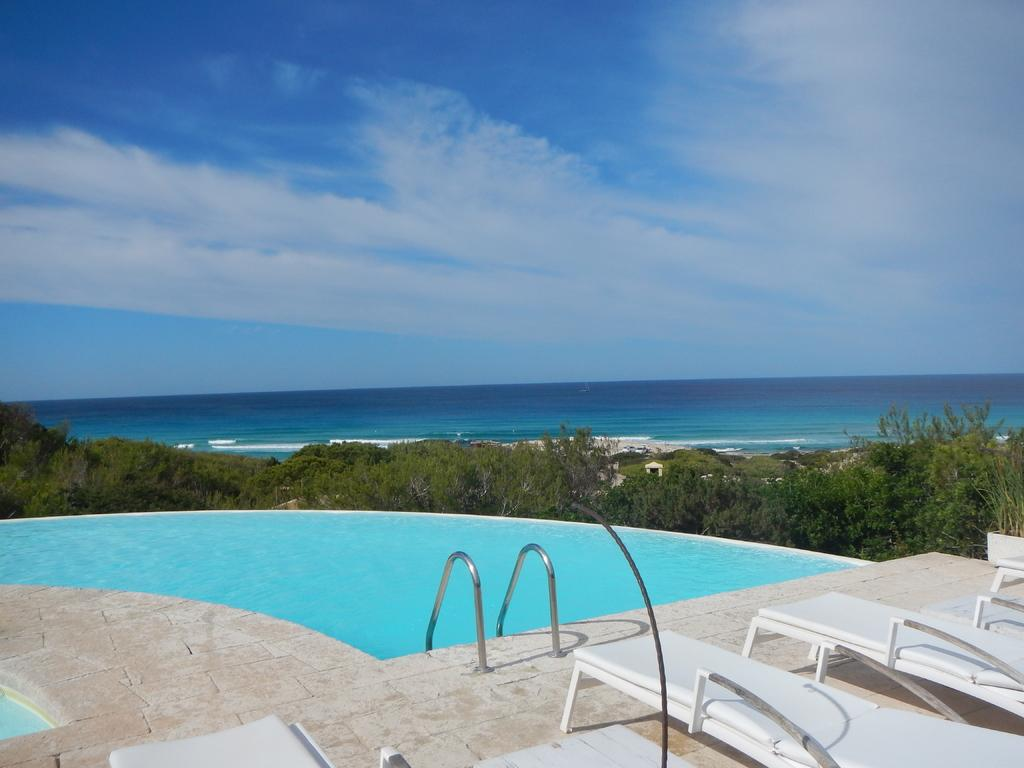What is the main feature of the image? There is a swimming pool in the image. What type of seating is available in the image? There are benches in the image. What type of vegetation is present in the image? There are trees in the image. What is the primary liquid visible in the image? There is water visible in the image. What is visible in the background of the image? The sky is visible in the image, and clouds are present in the sky. What type of nail is being hammered into the tree in the image? There is no nail being hammered into a tree in the image; there are only trees present. What advice is being given to the squirrel in the image? There is no squirrel present in the image, and therefore no advice can be given. 